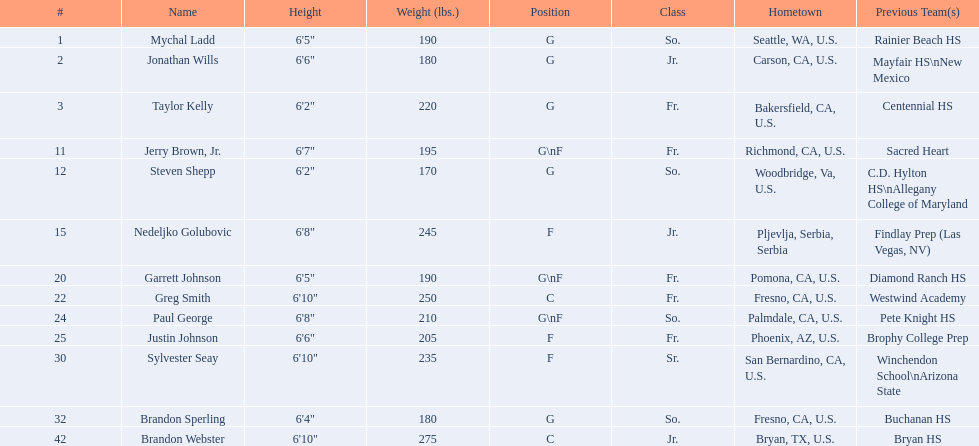What are the names of the basketball team players? Mychal Ladd, Jonathan Wills, Taylor Kelly, Jerry Brown, Jr., Steven Shepp, Nedeljko Golubovic, Garrett Johnson, Greg Smith, Paul George, Justin Johnson, Sylvester Seay, Brandon Sperling, Brandon Webster. Of these identify paul george and greg smith Greg Smith, Paul George. What are their corresponding heights? 6'10", 6'8". To who does the larger height correspond to? Greg Smith. 